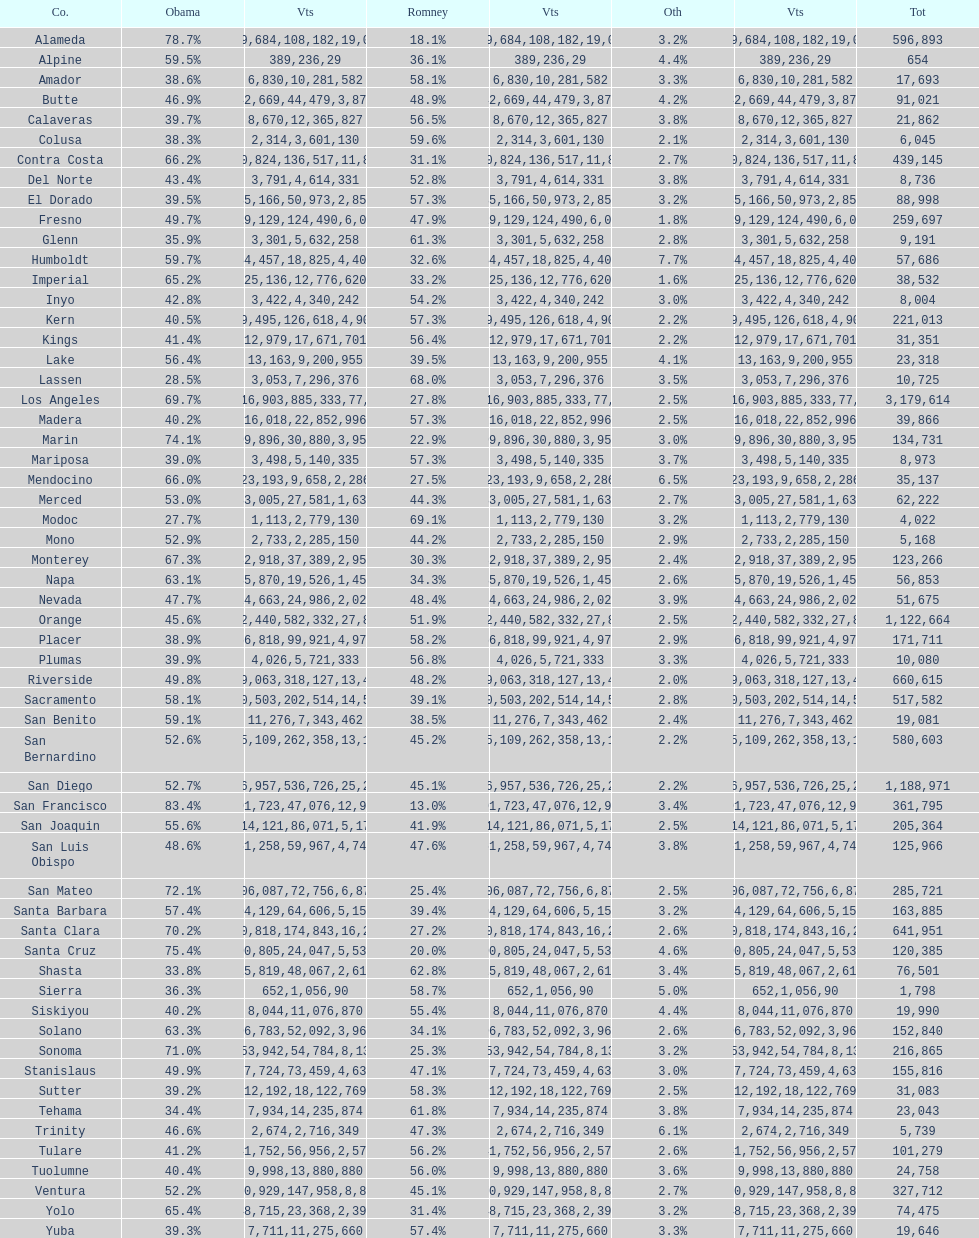Which count had the least number of votes for obama? Modoc. 